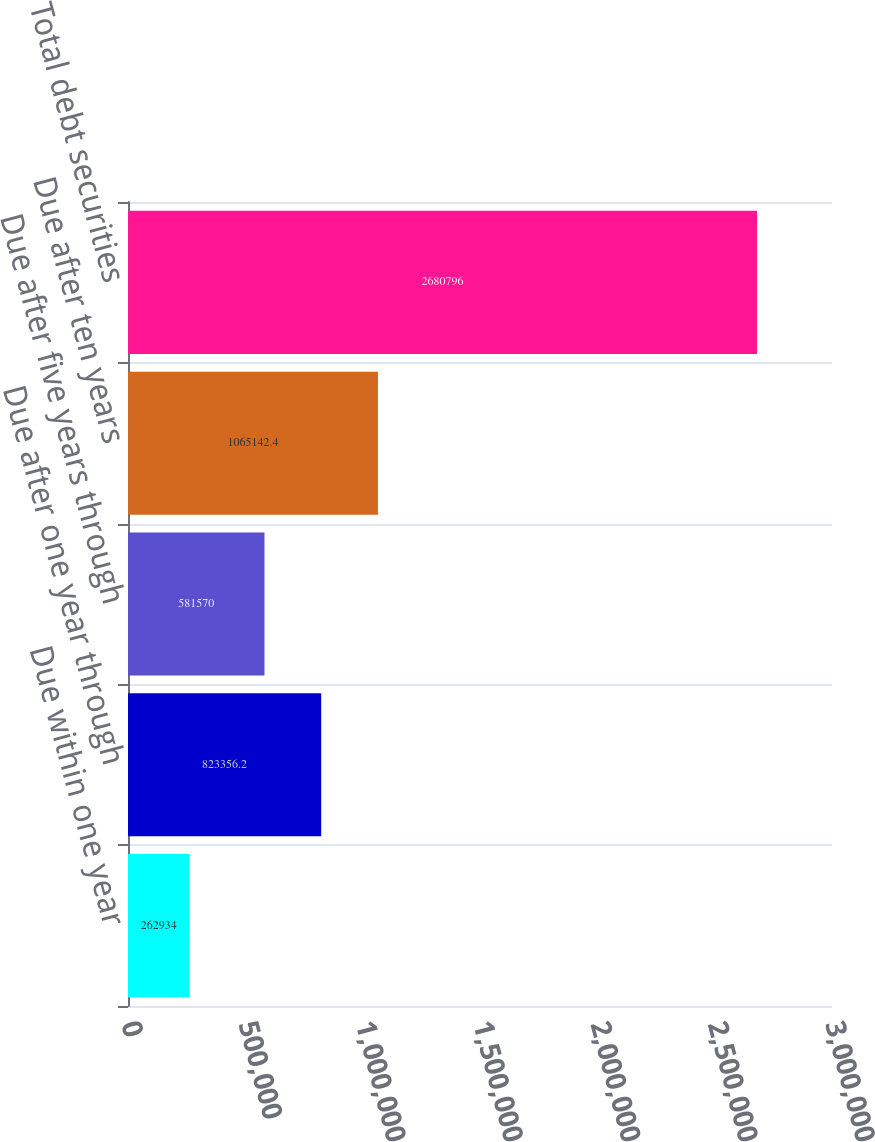Convert chart to OTSL. <chart><loc_0><loc_0><loc_500><loc_500><bar_chart><fcel>Due within one year<fcel>Due after one year through<fcel>Due after five years through<fcel>Due after ten years<fcel>Total debt securities<nl><fcel>262934<fcel>823356<fcel>581570<fcel>1.06514e+06<fcel>2.6808e+06<nl></chart> 